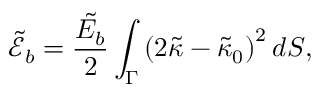Convert formula to latex. <formula><loc_0><loc_0><loc_500><loc_500>\tilde { \mathcal { E } } _ { b } = \frac { \tilde { E _ { b } } } { 2 } \int _ { \Gamma } \left ( 2 \tilde { \kappa } - \tilde { \kappa } _ { 0 } \right ) ^ { 2 } d S ,</formula> 